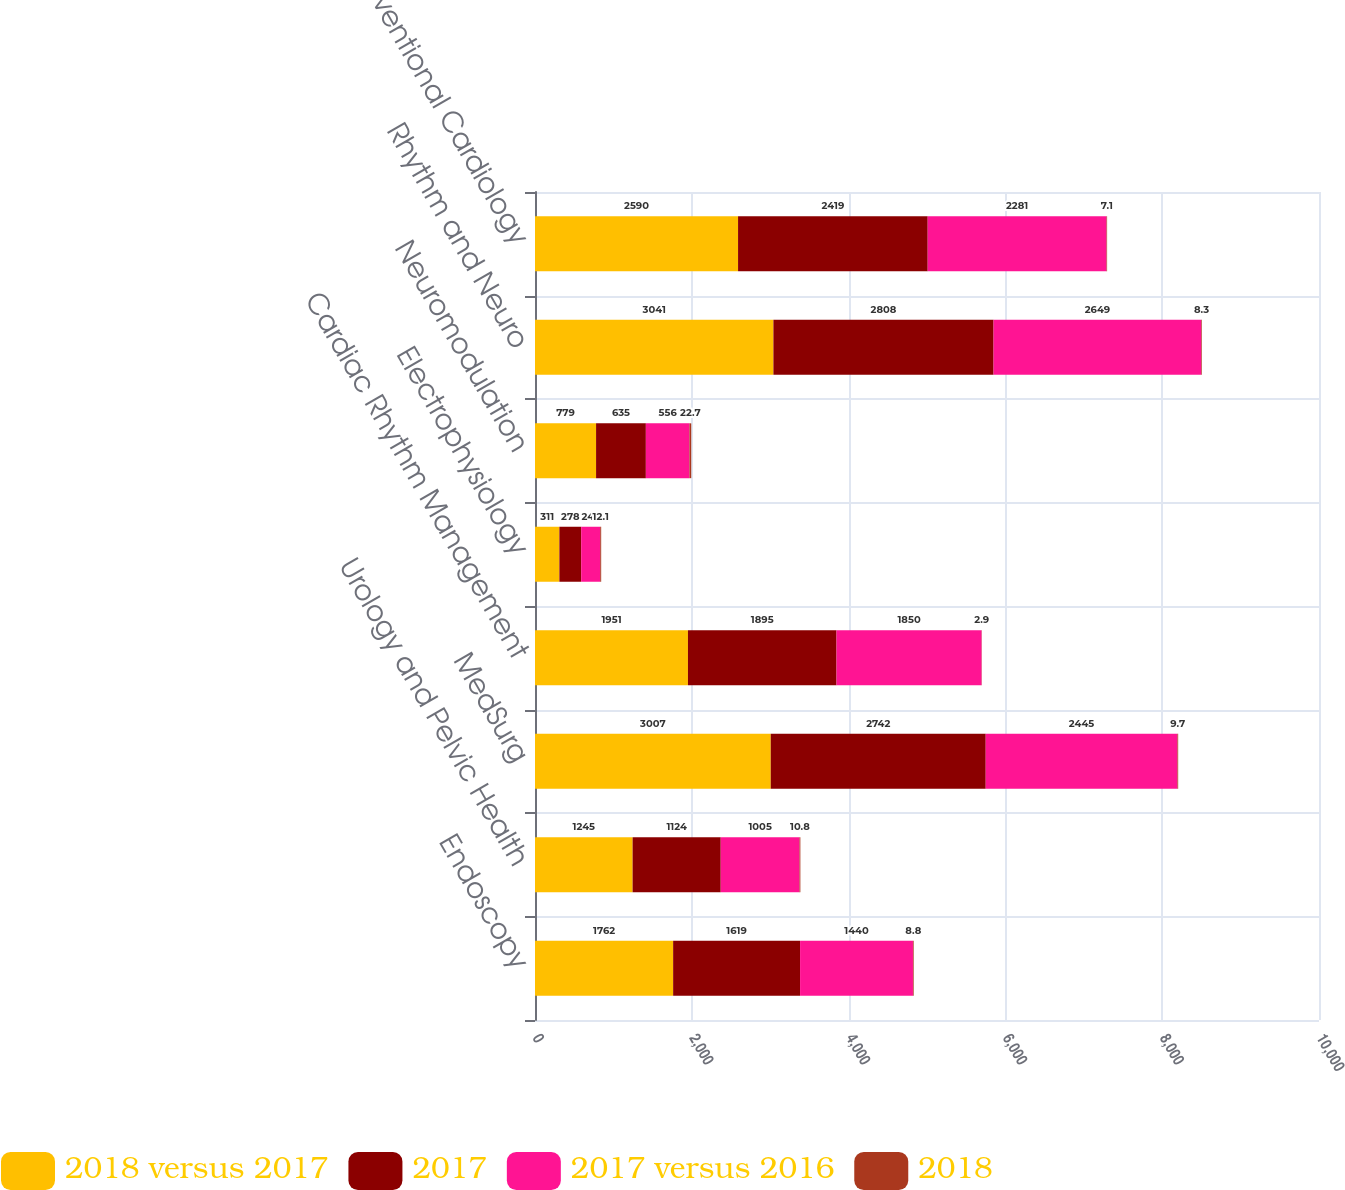Convert chart to OTSL. <chart><loc_0><loc_0><loc_500><loc_500><stacked_bar_chart><ecel><fcel>Endoscopy<fcel>Urology and Pelvic Health<fcel>MedSurg<fcel>Cardiac Rhythm Management<fcel>Electrophysiology<fcel>Neuromodulation<fcel>Rhythm and Neuro<fcel>Interventional Cardiology<nl><fcel>2018 versus 2017<fcel>1762<fcel>1245<fcel>3007<fcel>1951<fcel>311<fcel>779<fcel>3041<fcel>2590<nl><fcel>2017<fcel>1619<fcel>1124<fcel>2742<fcel>1895<fcel>278<fcel>635<fcel>2808<fcel>2419<nl><fcel>2017 versus 2016<fcel>1440<fcel>1005<fcel>2445<fcel>1850<fcel>243<fcel>556<fcel>2649<fcel>2281<nl><fcel>2018<fcel>8.8<fcel>10.8<fcel>9.7<fcel>2.9<fcel>12.1<fcel>22.7<fcel>8.3<fcel>7.1<nl></chart> 